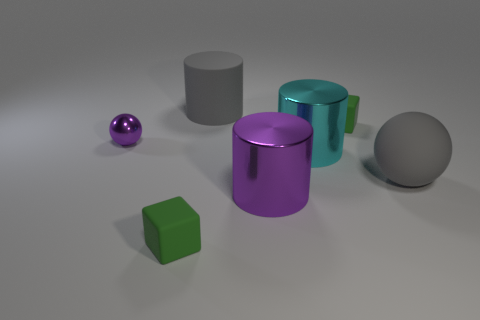Add 2 small matte things. How many objects exist? 9 Subtract all large metallic cylinders. How many cylinders are left? 1 Subtract all balls. How many objects are left? 5 Subtract 1 purple cylinders. How many objects are left? 6 Subtract all tiny green things. Subtract all big cyan shiny objects. How many objects are left? 4 Add 2 tiny shiny spheres. How many tiny shiny spheres are left? 3 Add 5 small blocks. How many small blocks exist? 7 